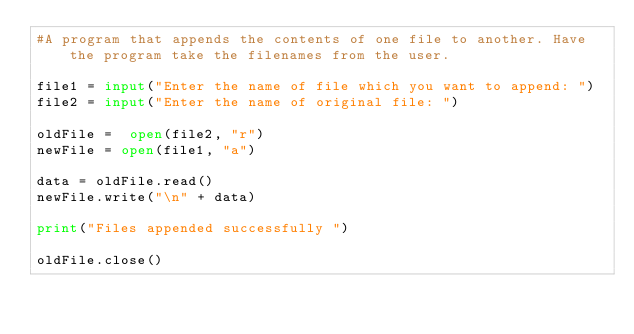<code> <loc_0><loc_0><loc_500><loc_500><_Python_>#A program that appends the contents of one file to another. Have the program take the filenames from the user. 

file1 = input("Enter the name of file which you want to append: ")
file2 = input("Enter the name of original file: ")

oldFile =  open(file2, "r")
newFile = open(file1, "a")

data = oldFile.read()
newFile.write("\n" + data)

print("Files appended successfully ")

oldFile.close()</code> 